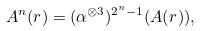Convert formula to latex. <formula><loc_0><loc_0><loc_500><loc_500>A ^ { n } ( r ) = ( \alpha ^ { \otimes 3 } ) ^ { 2 ^ { n } - 1 } ( A ( r ) ) ,</formula> 